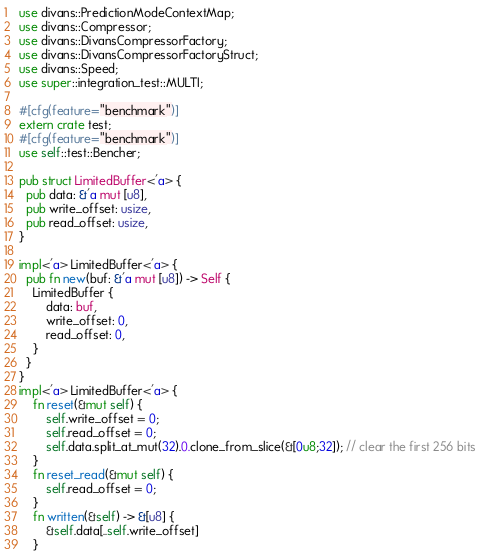<code> <loc_0><loc_0><loc_500><loc_500><_Rust_>use divans::PredictionModeContextMap;
use divans::Compressor;
use divans::DivansCompressorFactory;
use divans::DivansCompressorFactoryStruct;
use divans::Speed;
use super::integration_test::MULTI;

#[cfg(feature="benchmark")]
extern crate test;
#[cfg(feature="benchmark")]
use self::test::Bencher;

pub struct LimitedBuffer<'a> {
  pub data: &'a mut [u8],
  pub write_offset: usize,
  pub read_offset: usize,
}

impl<'a> LimitedBuffer<'a> {
  pub fn new(buf: &'a mut [u8]) -> Self {
    LimitedBuffer {
        data: buf,
        write_offset: 0,
        read_offset: 0,
    }
  }
}
impl<'a> LimitedBuffer<'a> {
    fn reset(&mut self) {
        self.write_offset = 0;
        self.read_offset = 0;
        self.data.split_at_mut(32).0.clone_from_slice(&[0u8;32]); // clear the first 256 bits
    }
    fn reset_read(&mut self) {
        self.read_offset = 0;
    }
    fn written(&self) -> &[u8] {
        &self.data[..self.write_offset]
    }</code> 